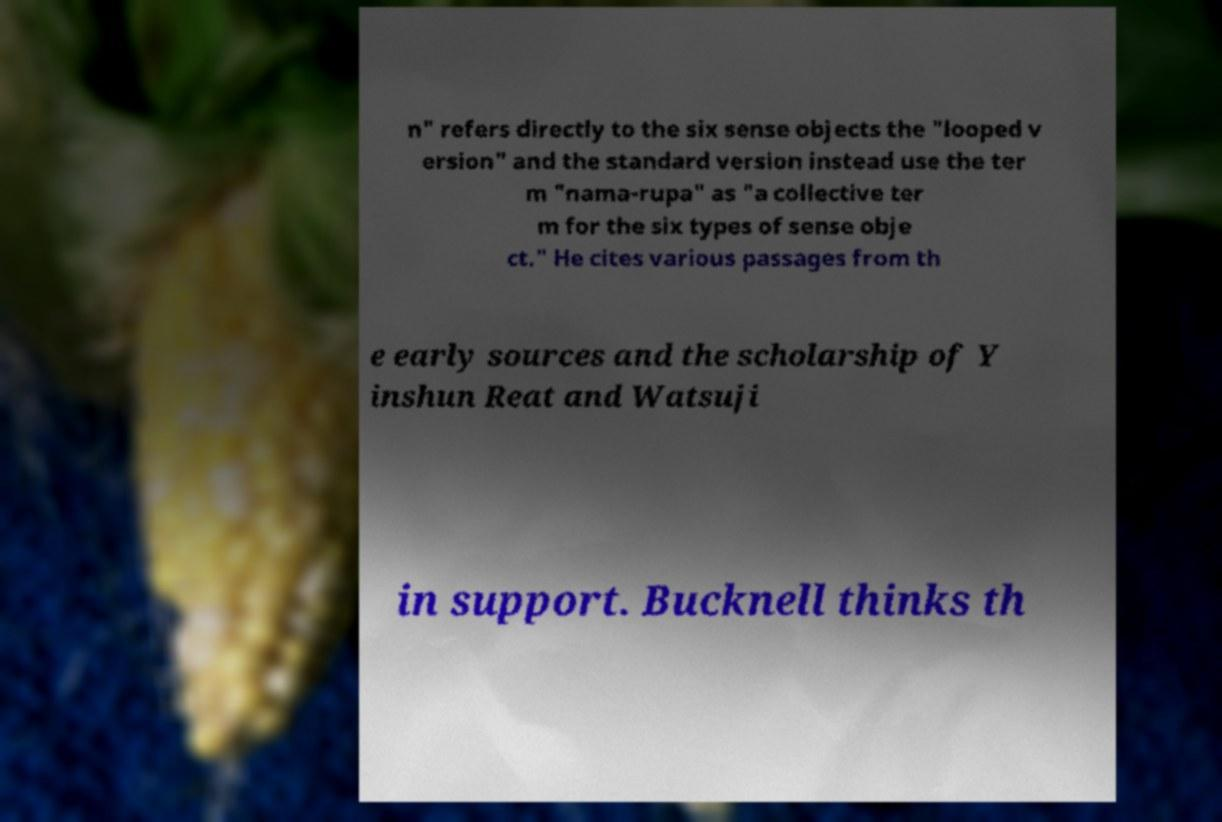Can you read and provide the text displayed in the image?This photo seems to have some interesting text. Can you extract and type it out for me? n" refers directly to the six sense objects the "looped v ersion" and the standard version instead use the ter m "nama-rupa" as "a collective ter m for the six types of sense obje ct." He cites various passages from th e early sources and the scholarship of Y inshun Reat and Watsuji in support. Bucknell thinks th 